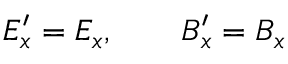<formula> <loc_0><loc_0><loc_500><loc_500>E _ { x } ^ { \prime } = E _ { x } , \quad B _ { x } ^ { \prime } = B _ { x }</formula> 